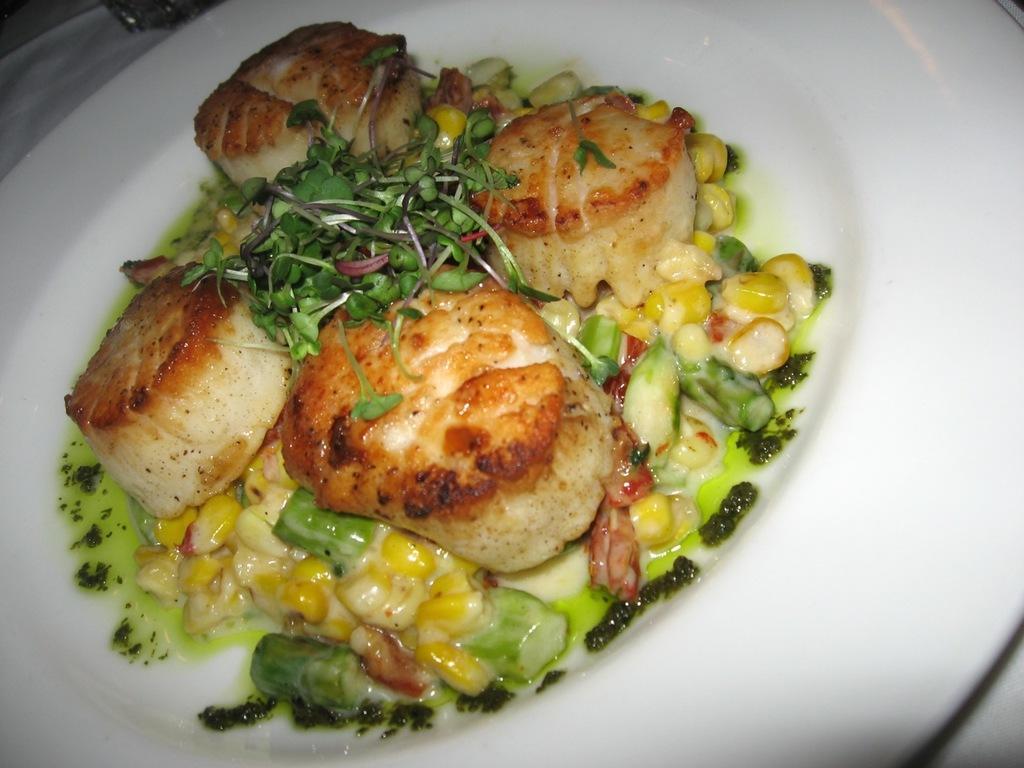In one or two sentences, can you explain what this image depicts? In this image there is a food item is kept into the white color plate as we can see in middle of this image. 